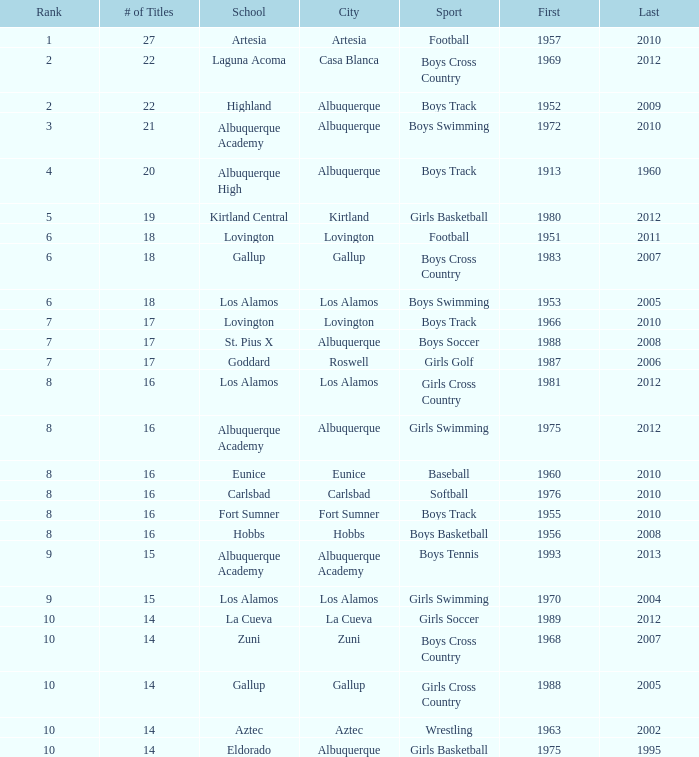What is the total rank number for Los Alamos' girls cross country? 1.0. 